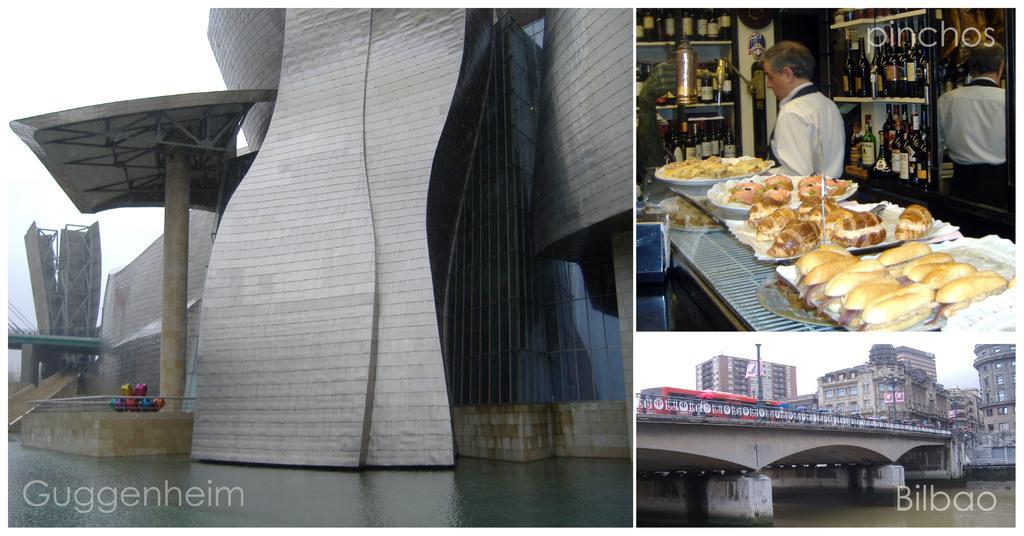Could you give a brief overview of what you see in this image? There is a collage of 3 images. In the left image I can see a building and water in the front. In the right bottom image there are vehicles on the bridge, there is water, poles and buildings. Above that image there are food items and a person is standing, there are glass bottles in the shelves. 